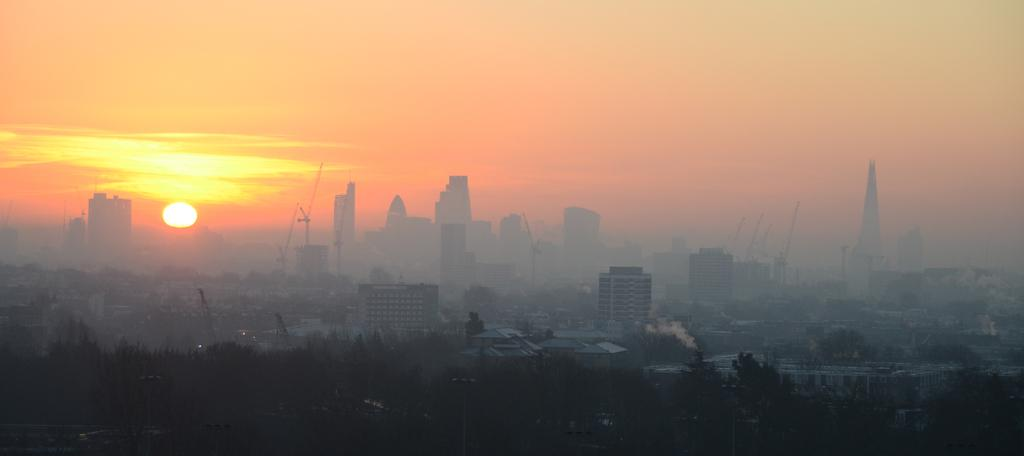What type of natural elements can be seen in the image? There are trees in the image. What type of man-made structures are present in the image? There are buildings in the image. Where is the sun located in the image? The sun is visible on the left side of the image. What is visible at the top of the image? The sky is visible at the top of the image. How many balls are being juggled by the trees in the image? There are no balls present in the image; it features trees and buildings. What type of harmony is being played by the sun in the image? The sun is a celestial body and does not play any form of harmony in the image. 